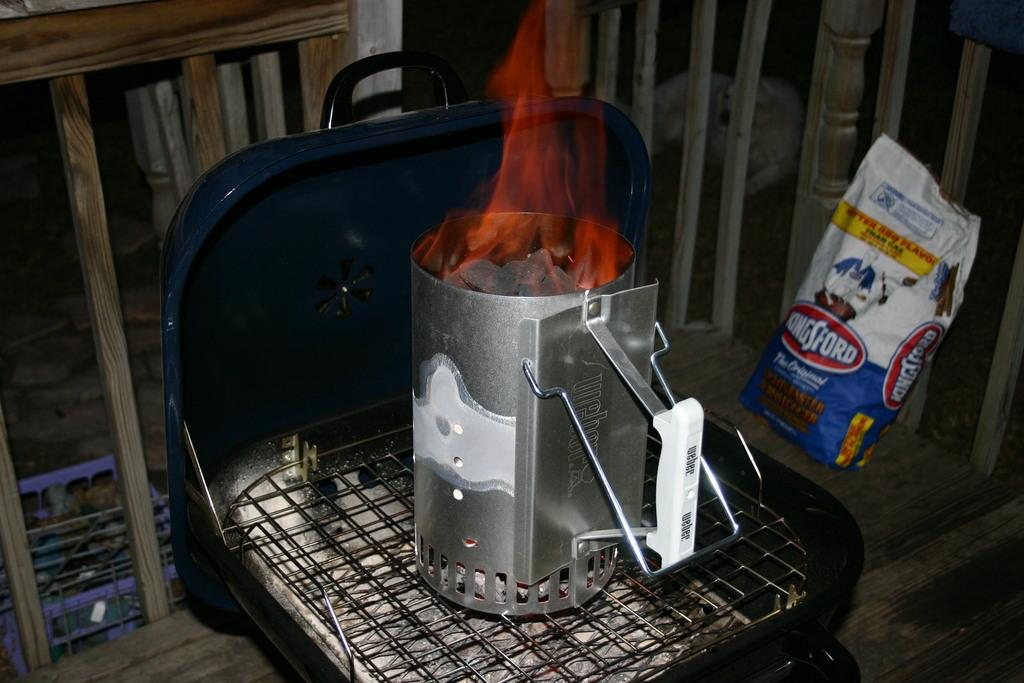<image>
Offer a succinct explanation of the picture presented. The coal was lit on fire to begin the BBQ. 